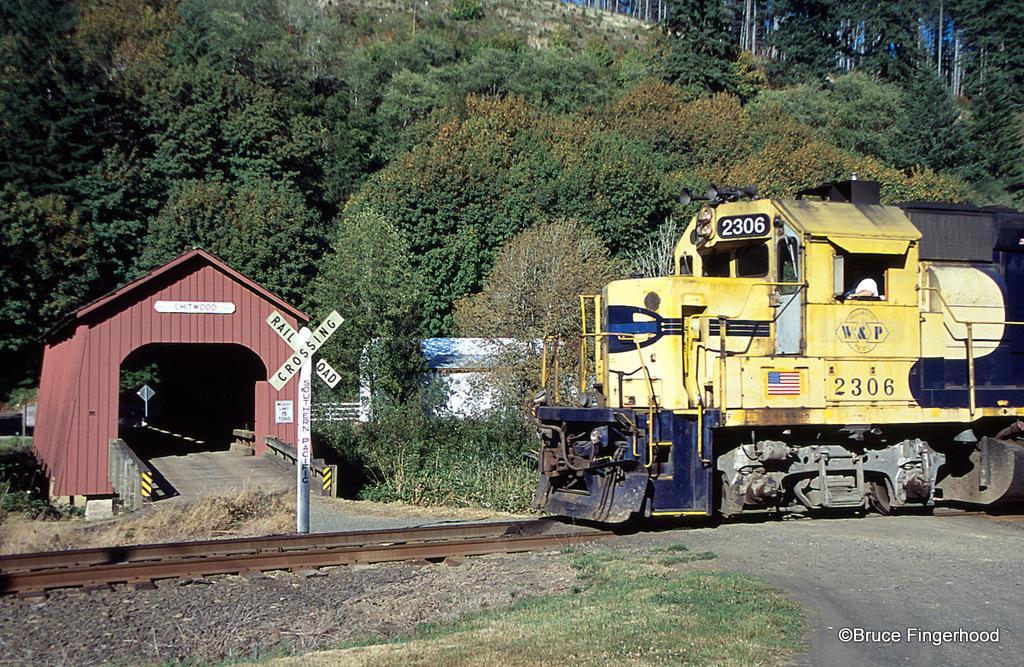In one or two sentences, can you explain what this image depicts? In this image on the right side we can see a train on the railway track, boards on the poles, grass on the ground and there is a person in the train. In the background we can see a shed, trees, plants, objects and there are trees on the hills also. 